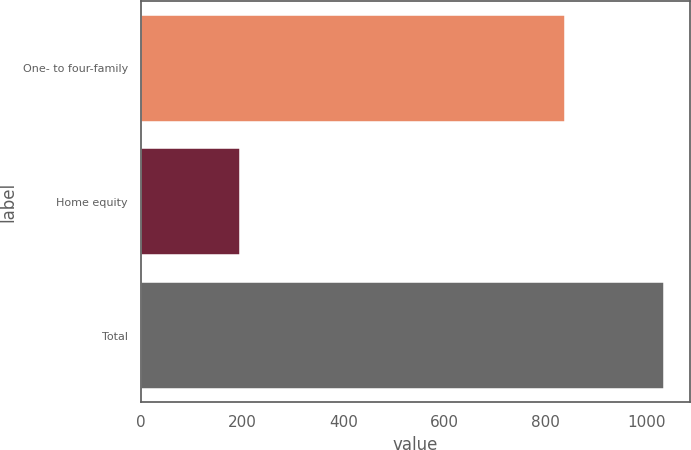Convert chart. <chart><loc_0><loc_0><loc_500><loc_500><bar_chart><fcel>One- to four-family<fcel>Home equity<fcel>Total<nl><fcel>838<fcel>195<fcel>1033<nl></chart> 